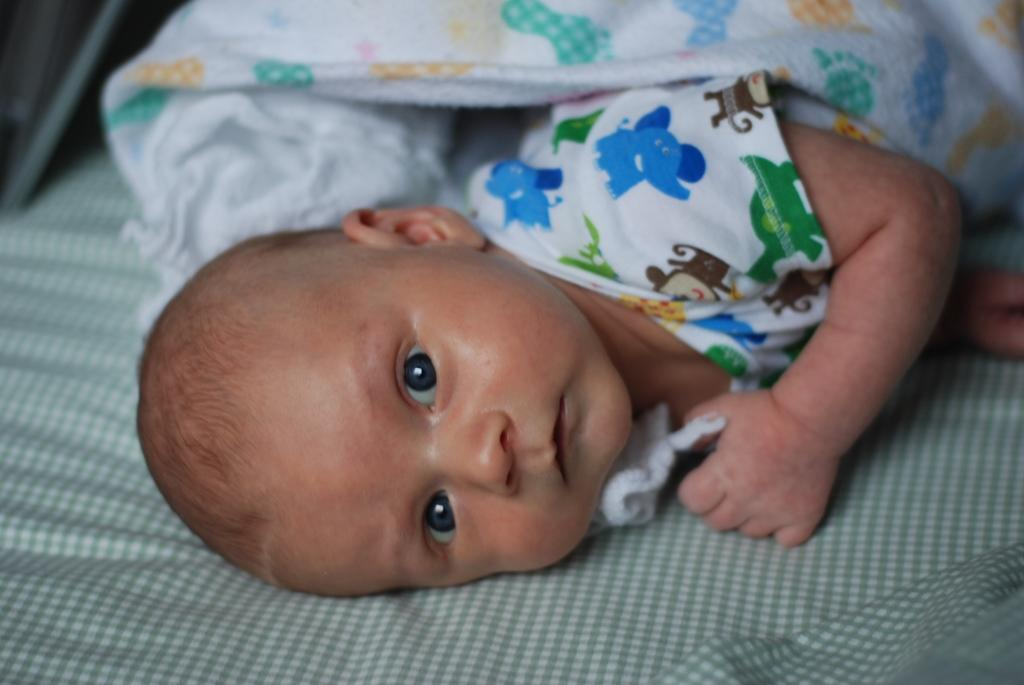What is the main subject of the picture? The main subject of the picture is a baby. Where is the baby located in the image? The baby is lying on a bed. Can you describe the bed in the image? The bed is green in color and has lines on it. What is the baby wearing in the picture? The baby is wearing a white cloth with pictures on it. What channel is the baby watching on the television in the image? There is no television present in the image, so it is not possible to determine what channel the baby might be watching. 